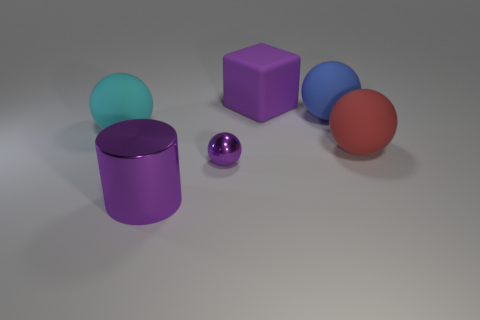Subtract all matte balls. How many balls are left? 1 Add 4 balls. How many objects exist? 10 Subtract 0 gray blocks. How many objects are left? 6 Subtract all spheres. How many objects are left? 2 Subtract all cyan cylinders. Subtract all blue balls. How many cylinders are left? 1 Subtract all blue cylinders. How many cyan spheres are left? 1 Subtract all big shiny cylinders. Subtract all large brown blocks. How many objects are left? 5 Add 5 balls. How many balls are left? 9 Add 4 blue things. How many blue things exist? 5 Subtract all purple balls. How many balls are left? 3 